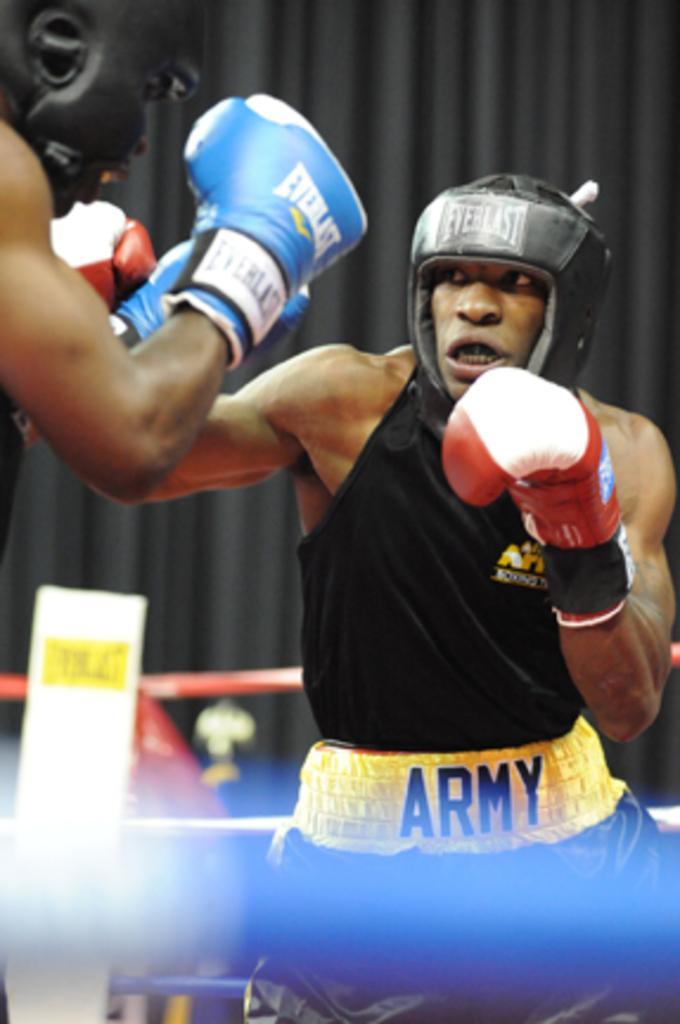How would you summarize this image in a sentence or two? In this image there are two people boxing. There are ropes. In the background of the image there is a black colored cloth. 